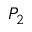<formula> <loc_0><loc_0><loc_500><loc_500>P _ { 2 }</formula> 